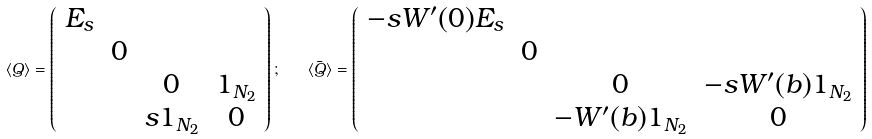Convert formula to latex. <formula><loc_0><loc_0><loc_500><loc_500>\langle Q \rangle = \left ( \begin{array} { c c c c } E _ { s } & & & \\ & { 0 } & & \\ & & { 0 } & { 1 } _ { N _ { 2 } } \\ & & s { 1 } _ { N _ { 2 } } & { 0 } \end{array} \right ) ; \quad \langle \bar { Q } \rangle = \left ( \begin{array} { c c c c } - s W ^ { \prime } ( 0 ) E _ { s } & & & \\ & { 0 } & & \\ & & { 0 } & - s W ^ { \prime } ( b ) { 1 } _ { N _ { 2 } } \\ & & - W ^ { \prime } ( b ) { 1 } _ { N _ { 2 } } & { 0 } \end{array} \right )</formula> 